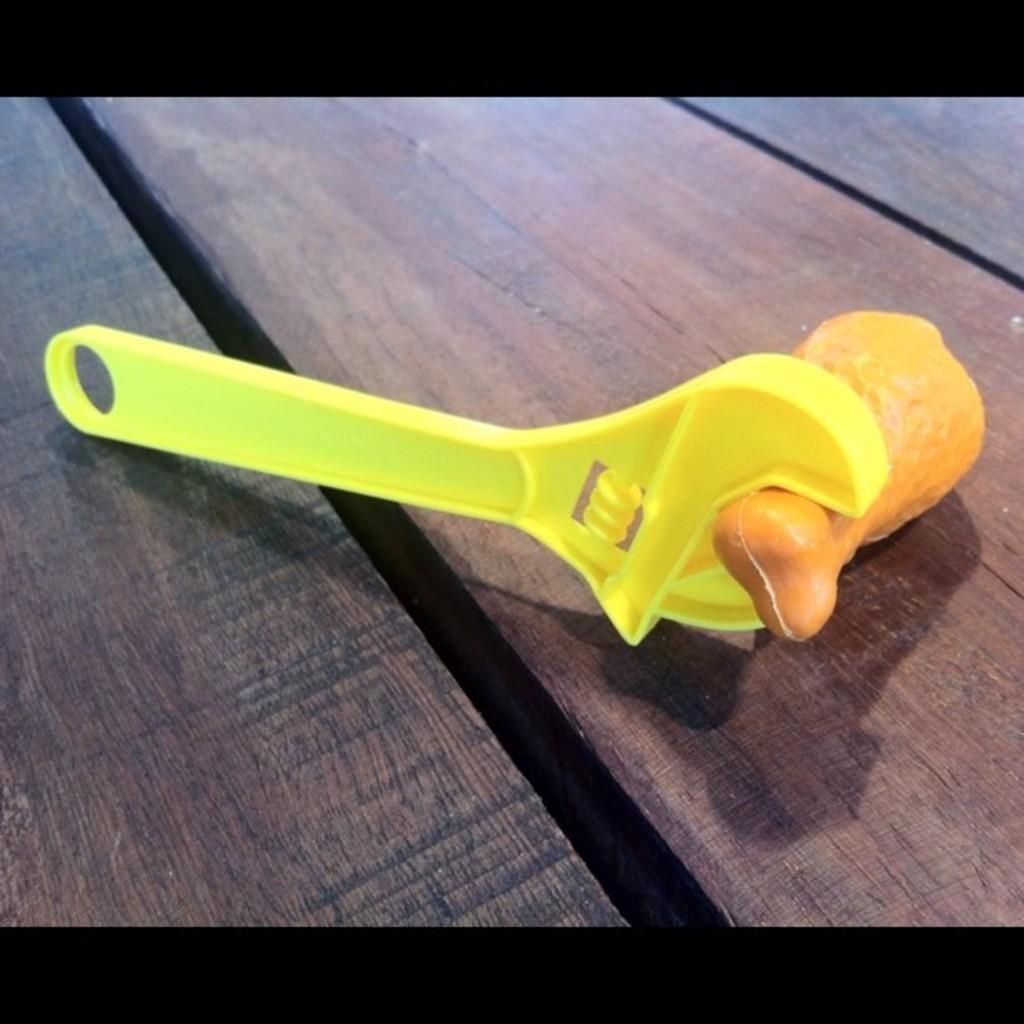Please provide a concise description of this image. In this picture I can see a plastic wrench and a plastic bone on the wooden plank. 